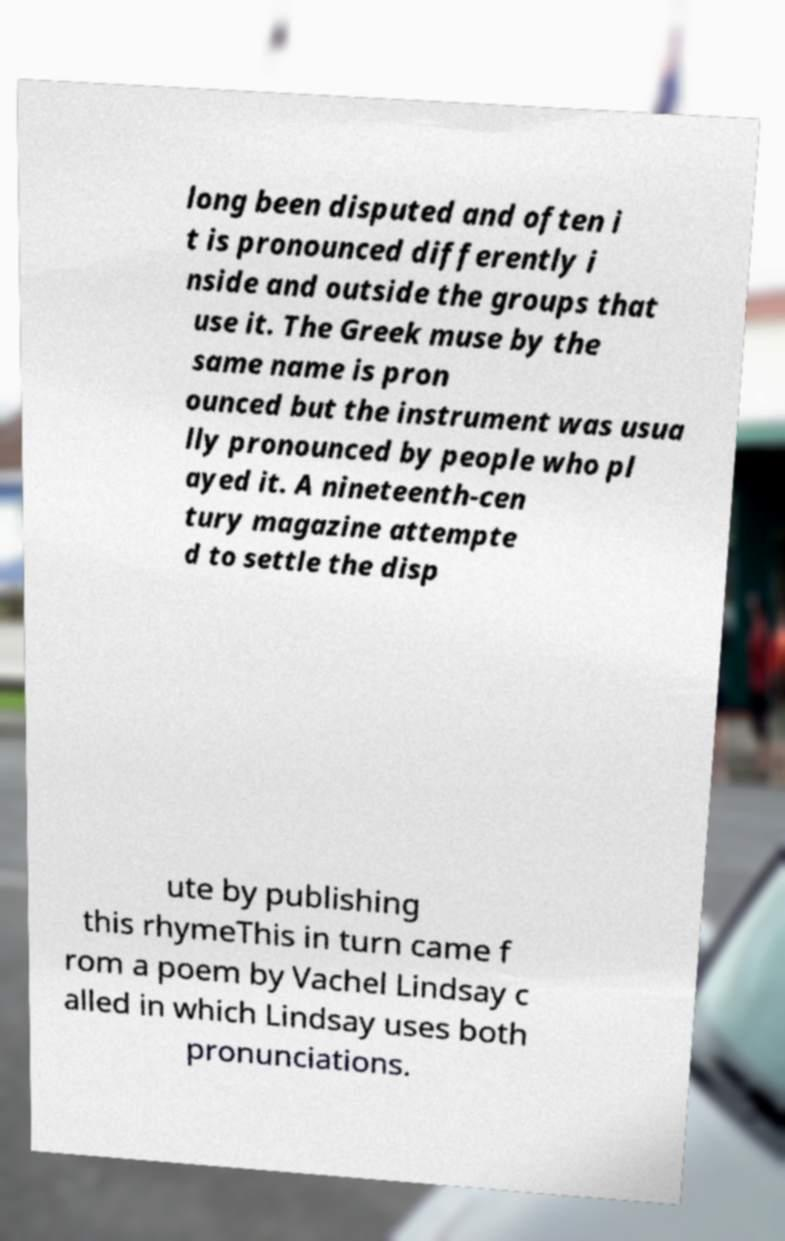For documentation purposes, I need the text within this image transcribed. Could you provide that? long been disputed and often i t is pronounced differently i nside and outside the groups that use it. The Greek muse by the same name is pron ounced but the instrument was usua lly pronounced by people who pl ayed it. A nineteenth-cen tury magazine attempte d to settle the disp ute by publishing this rhymeThis in turn came f rom a poem by Vachel Lindsay c alled in which Lindsay uses both pronunciations. 